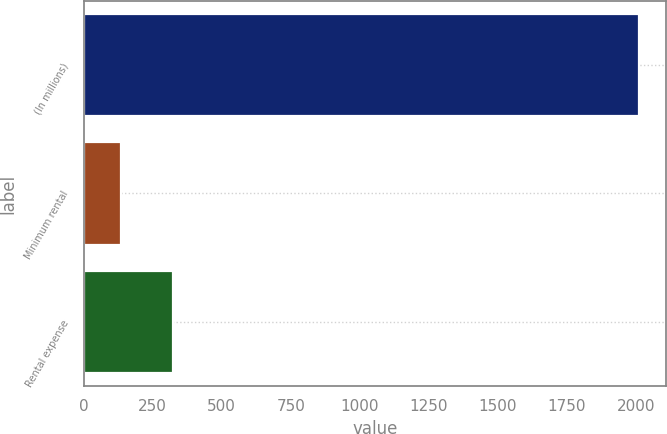<chart> <loc_0><loc_0><loc_500><loc_500><bar_chart><fcel>(In millions)<fcel>Minimum rental<fcel>Rental expense<nl><fcel>2010<fcel>135<fcel>322.5<nl></chart> 